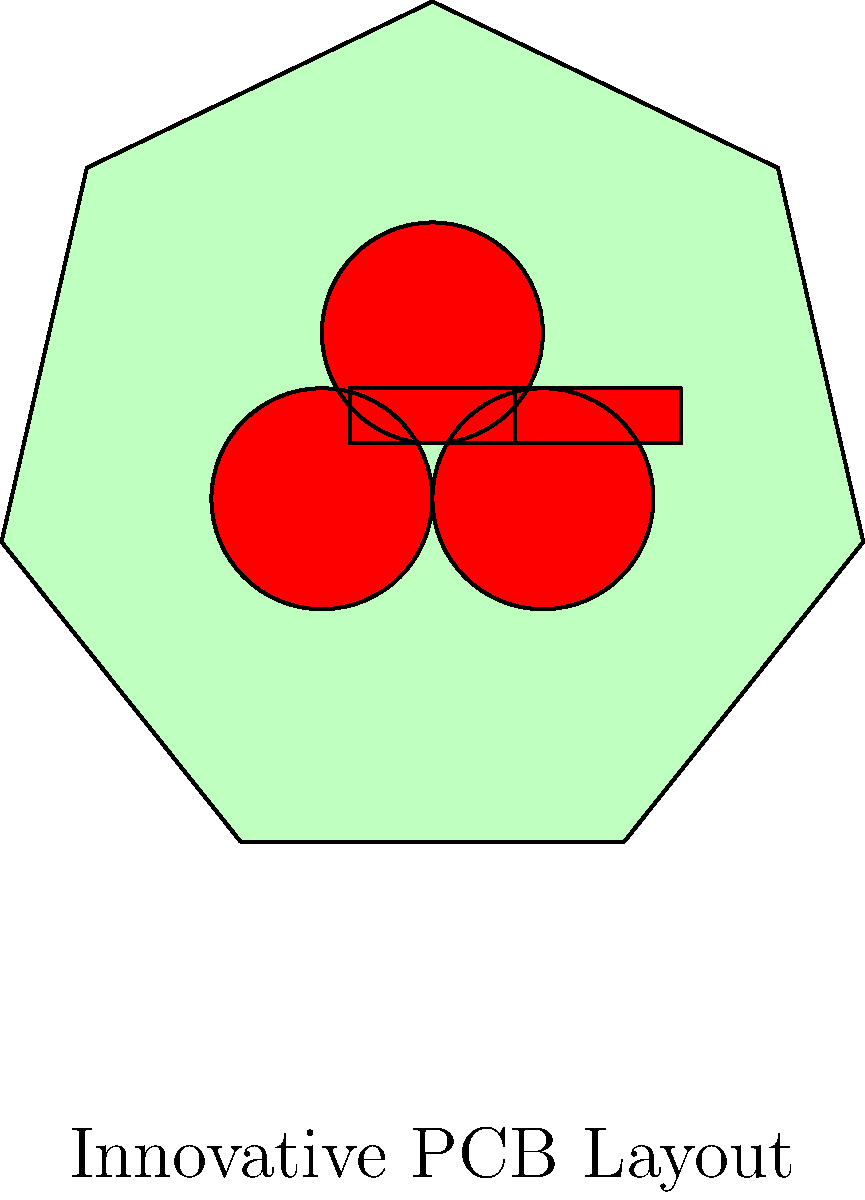Design an unconventional PCB layout for a simple audio amplifier circuit that maximizes both performance and aesthetic appeal. The layout should challenge traditional design norms while maintaining optimal signal integrity. How would you arrange the components to create a visually striking pattern that also minimizes electromagnetic interference? To design an unorthodox PCB layout that optimizes both performance and aesthetic appeal for an audio amplifier circuit, consider the following steps:

1. Embrace non-linear component placement:
   Instead of traditional rectangular layouts, arrange components in circular, spiral, or fractal patterns. This can create visually interesting designs while potentially reducing trace lengths.

2. Use organic trace routing:
   Employ curved and flowing traces instead of right-angled connections. This can reduce electromagnetic interference (EMI) and add to the aesthetic appeal.

3. Implement a ground plane with artistic cutouts:
   Create a ground plane that incorporates artistic patterns or shapes while maintaining proper grounding for optimal performance.

4. Utilize both sides of the PCB:
   Take advantage of both sides of the board to create a 3D circuit layout, allowing for more creative component placement and routing options.

5. Incorporate symmetry and balance:
   Arrange components in symmetrical patterns to achieve both visual appeal and electrical balance, which can help reduce noise and improve performance.

6. Use varied trace widths:
   Vary trace widths not only for current-carrying capacity but also for visual effect, creating a more dynamic and interesting layout.

7. Integrate shielding into the design:
   Incorporate EMI shielding as part of the artistic layout, using shaped copper pours or custom shield designs that complement the overall aesthetic.

8. Optimize component orientation:
   Rotate components to unconventional angles that both improve signal flow and create interesting visual patterns.

9. Utilize color and silkscreen artistically:
   Use different solder mask colors and silkscreen designs to enhance the visual appeal while also providing functional labeling and information.

10. Consider thermal management in the design:
    Integrate heat sinks and thermal vias into the artistic layout, using them as both functional and aesthetic elements.

By combining these techniques, you can create a PCB layout that challenges traditional design norms while maintaining optimal signal integrity and minimizing electromagnetic interference. The resulting board will be both a functional audio amplifier and a unique piece of electronic art.
Answer: Circular component arrangement with organic trace routing, artistic ground plane, and 3D layout utilizing both PCB sides. 